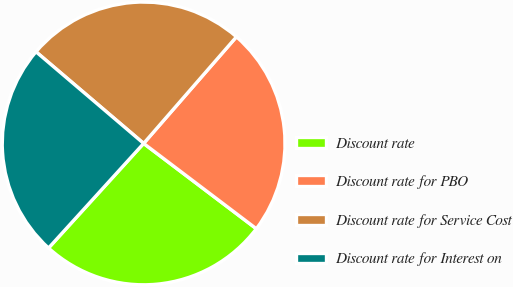Convert chart. <chart><loc_0><loc_0><loc_500><loc_500><pie_chart><fcel>Discount rate<fcel>Discount rate for PBO<fcel>Discount rate for Service Cost<fcel>Discount rate for Interest on<nl><fcel>26.43%<fcel>23.91%<fcel>25.17%<fcel>24.48%<nl></chart> 